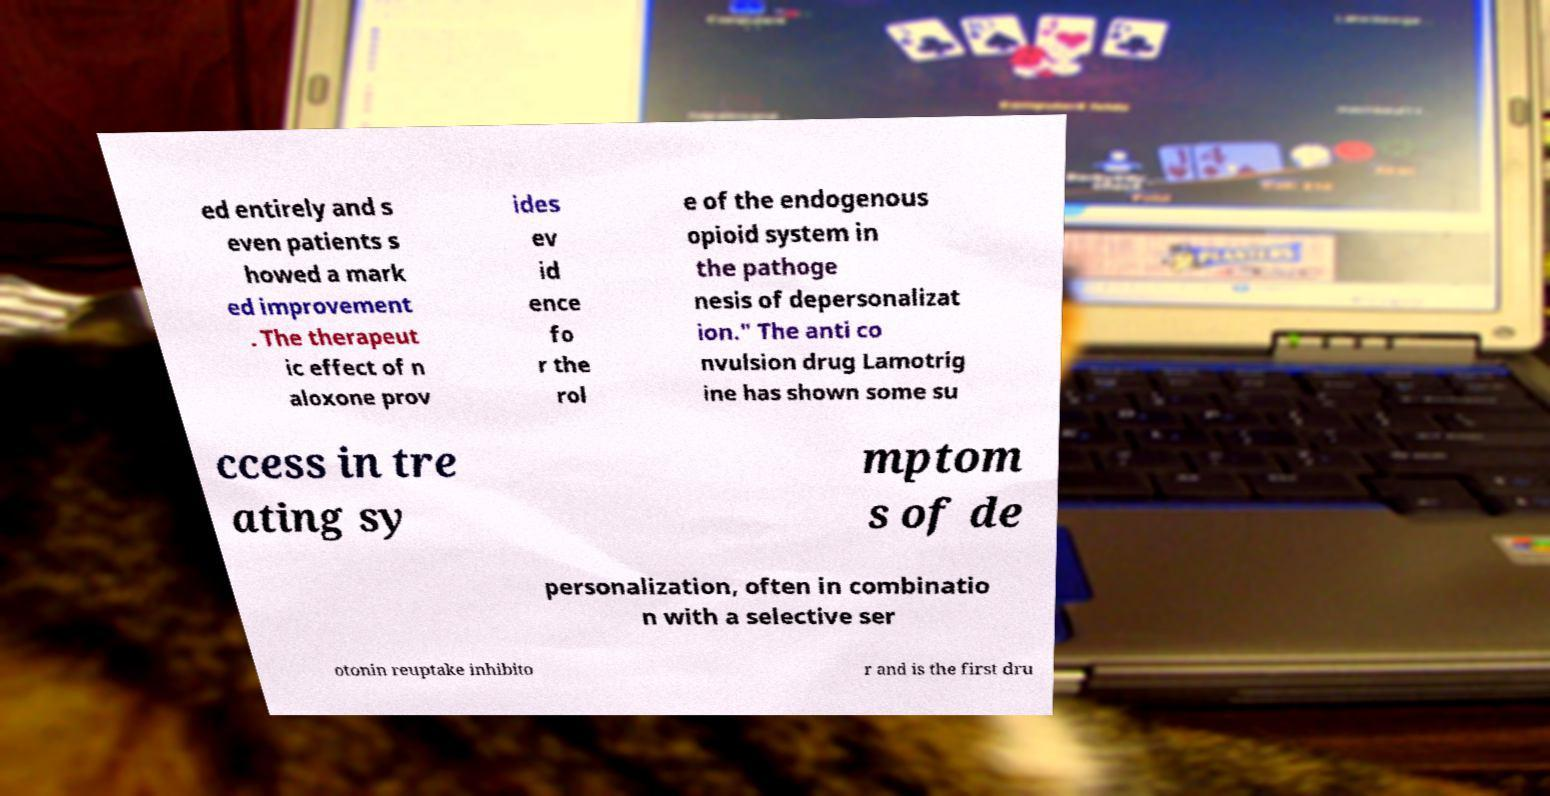Could you extract and type out the text from this image? ed entirely and s even patients s howed a mark ed improvement . The therapeut ic effect of n aloxone prov ides ev id ence fo r the rol e of the endogenous opioid system in the pathoge nesis of depersonalizat ion." The anti co nvulsion drug Lamotrig ine has shown some su ccess in tre ating sy mptom s of de personalization, often in combinatio n with a selective ser otonin reuptake inhibito r and is the first dru 